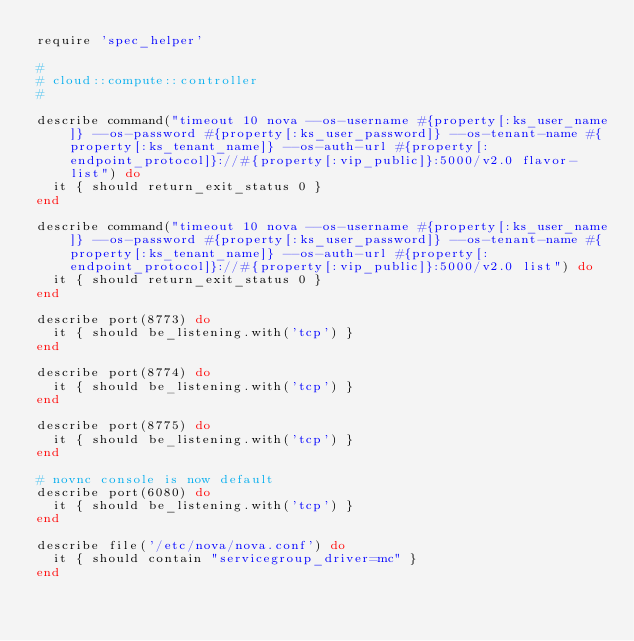Convert code to text. <code><loc_0><loc_0><loc_500><loc_500><_Ruby_>require 'spec_helper'

#
# cloud::compute::controller
#

describe command("timeout 10 nova --os-username #{property[:ks_user_name]} --os-password #{property[:ks_user_password]} --os-tenant-name #{property[:ks_tenant_name]} --os-auth-url #{property[:endpoint_protocol]}://#{property[:vip_public]}:5000/v2.0 flavor-list") do
  it { should return_exit_status 0 }
end

describe command("timeout 10 nova --os-username #{property[:ks_user_name]} --os-password #{property[:ks_user_password]} --os-tenant-name #{property[:ks_tenant_name]} --os-auth-url #{property[:endpoint_protocol]}://#{property[:vip_public]}:5000/v2.0 list") do
  it { should return_exit_status 0 }
end

describe port(8773) do
  it { should be_listening.with('tcp') }
end

describe port(8774) do
  it { should be_listening.with('tcp') }
end

describe port(8775) do
  it { should be_listening.with('tcp') }
end

# novnc console is now default
describe port(6080) do
  it { should be_listening.with('tcp') }
end

describe file('/etc/nova/nova.conf') do
  it { should contain "servicegroup_driver=mc" }
end
</code> 